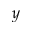Convert formula to latex. <formula><loc_0><loc_0><loc_500><loc_500>y</formula> 